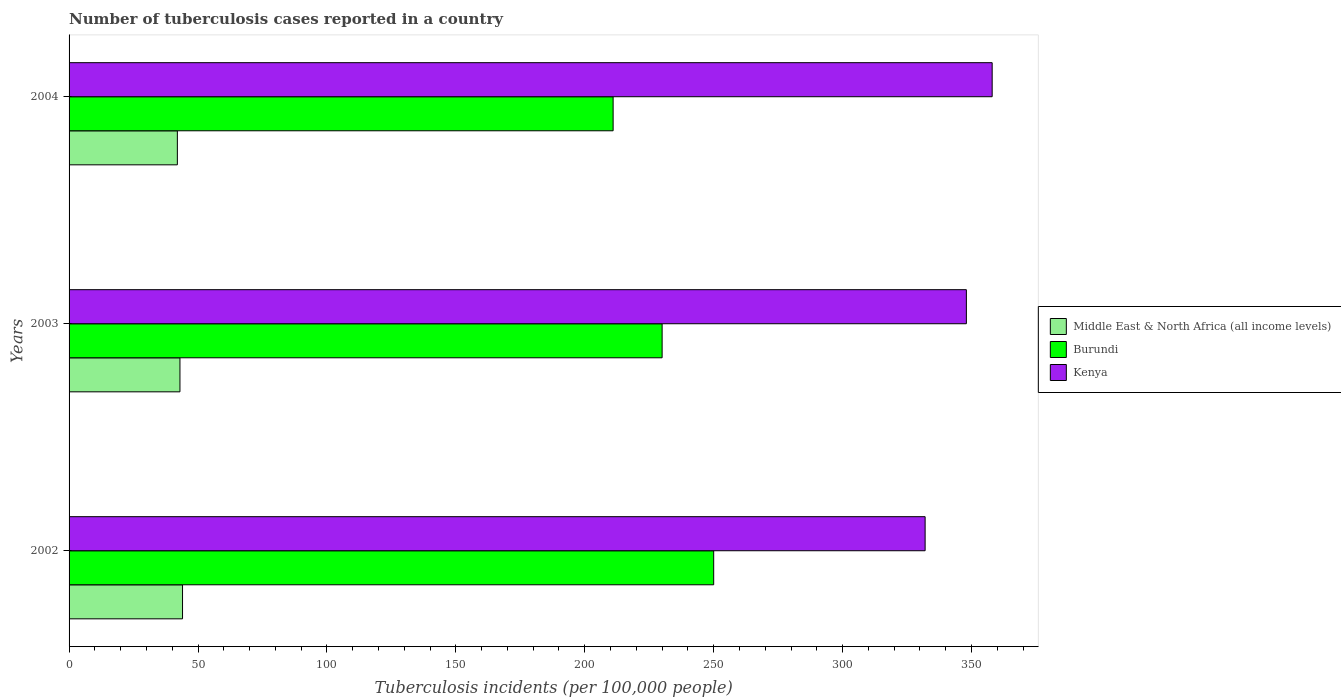How many different coloured bars are there?
Keep it short and to the point. 3. How many bars are there on the 1st tick from the top?
Give a very brief answer. 3. What is the label of the 3rd group of bars from the top?
Make the answer very short. 2002. In how many cases, is the number of bars for a given year not equal to the number of legend labels?
Provide a short and direct response. 0. What is the number of tuberculosis cases reported in in Kenya in 2004?
Your answer should be compact. 358. Across all years, what is the maximum number of tuberculosis cases reported in in Burundi?
Ensure brevity in your answer.  250. Across all years, what is the minimum number of tuberculosis cases reported in in Kenya?
Offer a terse response. 332. In which year was the number of tuberculosis cases reported in in Burundi maximum?
Offer a very short reply. 2002. In which year was the number of tuberculosis cases reported in in Burundi minimum?
Your answer should be very brief. 2004. What is the total number of tuberculosis cases reported in in Middle East & North Africa (all income levels) in the graph?
Your response must be concise. 129. What is the difference between the number of tuberculosis cases reported in in Burundi in 2003 and that in 2004?
Make the answer very short. 19. What is the difference between the number of tuberculosis cases reported in in Burundi in 2004 and the number of tuberculosis cases reported in in Middle East & North Africa (all income levels) in 2002?
Ensure brevity in your answer.  167. What is the average number of tuberculosis cases reported in in Middle East & North Africa (all income levels) per year?
Keep it short and to the point. 43. In the year 2003, what is the difference between the number of tuberculosis cases reported in in Burundi and number of tuberculosis cases reported in in Middle East & North Africa (all income levels)?
Make the answer very short. 187. In how many years, is the number of tuberculosis cases reported in in Middle East & North Africa (all income levels) greater than 190 ?
Your answer should be compact. 0. What is the ratio of the number of tuberculosis cases reported in in Kenya in 2002 to that in 2004?
Provide a short and direct response. 0.93. Is the number of tuberculosis cases reported in in Kenya in 2002 less than that in 2004?
Keep it short and to the point. Yes. What is the difference between the highest and the second highest number of tuberculosis cases reported in in Burundi?
Give a very brief answer. 20. What is the difference between the highest and the lowest number of tuberculosis cases reported in in Burundi?
Your response must be concise. 39. What does the 1st bar from the top in 2004 represents?
Your answer should be compact. Kenya. What does the 2nd bar from the bottom in 2004 represents?
Provide a short and direct response. Burundi. Is it the case that in every year, the sum of the number of tuberculosis cases reported in in Burundi and number of tuberculosis cases reported in in Kenya is greater than the number of tuberculosis cases reported in in Middle East & North Africa (all income levels)?
Provide a succinct answer. Yes. Are the values on the major ticks of X-axis written in scientific E-notation?
Offer a very short reply. No. Does the graph contain any zero values?
Your answer should be compact. No. Does the graph contain grids?
Offer a very short reply. No. How many legend labels are there?
Your answer should be compact. 3. What is the title of the graph?
Keep it short and to the point. Number of tuberculosis cases reported in a country. What is the label or title of the X-axis?
Give a very brief answer. Tuberculosis incidents (per 100,0 people). What is the label or title of the Y-axis?
Make the answer very short. Years. What is the Tuberculosis incidents (per 100,000 people) in Burundi in 2002?
Your response must be concise. 250. What is the Tuberculosis incidents (per 100,000 people) in Kenya in 2002?
Keep it short and to the point. 332. What is the Tuberculosis incidents (per 100,000 people) of Burundi in 2003?
Your answer should be very brief. 230. What is the Tuberculosis incidents (per 100,000 people) of Kenya in 2003?
Give a very brief answer. 348. What is the Tuberculosis incidents (per 100,000 people) of Middle East & North Africa (all income levels) in 2004?
Your response must be concise. 42. What is the Tuberculosis incidents (per 100,000 people) of Burundi in 2004?
Provide a short and direct response. 211. What is the Tuberculosis incidents (per 100,000 people) in Kenya in 2004?
Ensure brevity in your answer.  358. Across all years, what is the maximum Tuberculosis incidents (per 100,000 people) in Burundi?
Ensure brevity in your answer.  250. Across all years, what is the maximum Tuberculosis incidents (per 100,000 people) of Kenya?
Your answer should be compact. 358. Across all years, what is the minimum Tuberculosis incidents (per 100,000 people) in Burundi?
Make the answer very short. 211. Across all years, what is the minimum Tuberculosis incidents (per 100,000 people) of Kenya?
Offer a very short reply. 332. What is the total Tuberculosis incidents (per 100,000 people) in Middle East & North Africa (all income levels) in the graph?
Make the answer very short. 129. What is the total Tuberculosis incidents (per 100,000 people) of Burundi in the graph?
Your response must be concise. 691. What is the total Tuberculosis incidents (per 100,000 people) in Kenya in the graph?
Your answer should be compact. 1038. What is the difference between the Tuberculosis incidents (per 100,000 people) of Burundi in 2002 and that in 2003?
Your response must be concise. 20. What is the difference between the Tuberculosis incidents (per 100,000 people) of Kenya in 2002 and that in 2003?
Provide a short and direct response. -16. What is the difference between the Tuberculosis incidents (per 100,000 people) in Middle East & North Africa (all income levels) in 2002 and the Tuberculosis incidents (per 100,000 people) in Burundi in 2003?
Ensure brevity in your answer.  -186. What is the difference between the Tuberculosis incidents (per 100,000 people) in Middle East & North Africa (all income levels) in 2002 and the Tuberculosis incidents (per 100,000 people) in Kenya in 2003?
Provide a short and direct response. -304. What is the difference between the Tuberculosis incidents (per 100,000 people) of Burundi in 2002 and the Tuberculosis incidents (per 100,000 people) of Kenya in 2003?
Your answer should be compact. -98. What is the difference between the Tuberculosis incidents (per 100,000 people) of Middle East & North Africa (all income levels) in 2002 and the Tuberculosis incidents (per 100,000 people) of Burundi in 2004?
Your response must be concise. -167. What is the difference between the Tuberculosis incidents (per 100,000 people) in Middle East & North Africa (all income levels) in 2002 and the Tuberculosis incidents (per 100,000 people) in Kenya in 2004?
Provide a short and direct response. -314. What is the difference between the Tuberculosis incidents (per 100,000 people) of Burundi in 2002 and the Tuberculosis incidents (per 100,000 people) of Kenya in 2004?
Your answer should be compact. -108. What is the difference between the Tuberculosis incidents (per 100,000 people) in Middle East & North Africa (all income levels) in 2003 and the Tuberculosis incidents (per 100,000 people) in Burundi in 2004?
Make the answer very short. -168. What is the difference between the Tuberculosis incidents (per 100,000 people) in Middle East & North Africa (all income levels) in 2003 and the Tuberculosis incidents (per 100,000 people) in Kenya in 2004?
Keep it short and to the point. -315. What is the difference between the Tuberculosis incidents (per 100,000 people) of Burundi in 2003 and the Tuberculosis incidents (per 100,000 people) of Kenya in 2004?
Keep it short and to the point. -128. What is the average Tuberculosis incidents (per 100,000 people) of Burundi per year?
Your response must be concise. 230.33. What is the average Tuberculosis incidents (per 100,000 people) in Kenya per year?
Your answer should be very brief. 346. In the year 2002, what is the difference between the Tuberculosis incidents (per 100,000 people) in Middle East & North Africa (all income levels) and Tuberculosis incidents (per 100,000 people) in Burundi?
Keep it short and to the point. -206. In the year 2002, what is the difference between the Tuberculosis incidents (per 100,000 people) in Middle East & North Africa (all income levels) and Tuberculosis incidents (per 100,000 people) in Kenya?
Offer a very short reply. -288. In the year 2002, what is the difference between the Tuberculosis incidents (per 100,000 people) in Burundi and Tuberculosis incidents (per 100,000 people) in Kenya?
Offer a very short reply. -82. In the year 2003, what is the difference between the Tuberculosis incidents (per 100,000 people) in Middle East & North Africa (all income levels) and Tuberculosis incidents (per 100,000 people) in Burundi?
Make the answer very short. -187. In the year 2003, what is the difference between the Tuberculosis incidents (per 100,000 people) in Middle East & North Africa (all income levels) and Tuberculosis incidents (per 100,000 people) in Kenya?
Provide a succinct answer. -305. In the year 2003, what is the difference between the Tuberculosis incidents (per 100,000 people) in Burundi and Tuberculosis incidents (per 100,000 people) in Kenya?
Provide a succinct answer. -118. In the year 2004, what is the difference between the Tuberculosis incidents (per 100,000 people) of Middle East & North Africa (all income levels) and Tuberculosis incidents (per 100,000 people) of Burundi?
Ensure brevity in your answer.  -169. In the year 2004, what is the difference between the Tuberculosis incidents (per 100,000 people) of Middle East & North Africa (all income levels) and Tuberculosis incidents (per 100,000 people) of Kenya?
Your response must be concise. -316. In the year 2004, what is the difference between the Tuberculosis incidents (per 100,000 people) of Burundi and Tuberculosis incidents (per 100,000 people) of Kenya?
Offer a very short reply. -147. What is the ratio of the Tuberculosis incidents (per 100,000 people) in Middle East & North Africa (all income levels) in 2002 to that in 2003?
Make the answer very short. 1.02. What is the ratio of the Tuberculosis incidents (per 100,000 people) of Burundi in 2002 to that in 2003?
Keep it short and to the point. 1.09. What is the ratio of the Tuberculosis incidents (per 100,000 people) in Kenya in 2002 to that in 2003?
Offer a very short reply. 0.95. What is the ratio of the Tuberculosis incidents (per 100,000 people) of Middle East & North Africa (all income levels) in 2002 to that in 2004?
Your answer should be compact. 1.05. What is the ratio of the Tuberculosis incidents (per 100,000 people) of Burundi in 2002 to that in 2004?
Your response must be concise. 1.18. What is the ratio of the Tuberculosis incidents (per 100,000 people) in Kenya in 2002 to that in 2004?
Offer a very short reply. 0.93. What is the ratio of the Tuberculosis incidents (per 100,000 people) in Middle East & North Africa (all income levels) in 2003 to that in 2004?
Your answer should be very brief. 1.02. What is the ratio of the Tuberculosis incidents (per 100,000 people) of Burundi in 2003 to that in 2004?
Your response must be concise. 1.09. What is the ratio of the Tuberculosis incidents (per 100,000 people) in Kenya in 2003 to that in 2004?
Provide a succinct answer. 0.97. What is the difference between the highest and the second highest Tuberculosis incidents (per 100,000 people) in Burundi?
Offer a very short reply. 20. What is the difference between the highest and the second highest Tuberculosis incidents (per 100,000 people) in Kenya?
Provide a succinct answer. 10. What is the difference between the highest and the lowest Tuberculosis incidents (per 100,000 people) of Kenya?
Ensure brevity in your answer.  26. 